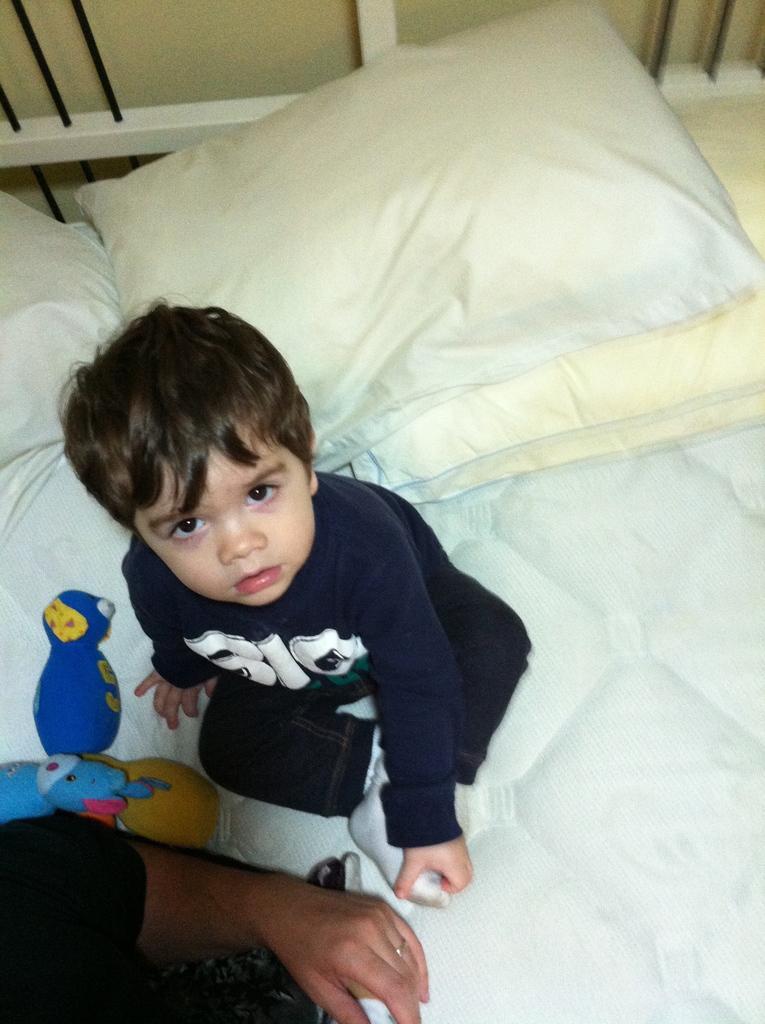Could you give a brief overview of what you see in this image? As we can see in the image, there is a boy sitting on bed and on bed there are few white color windows. 